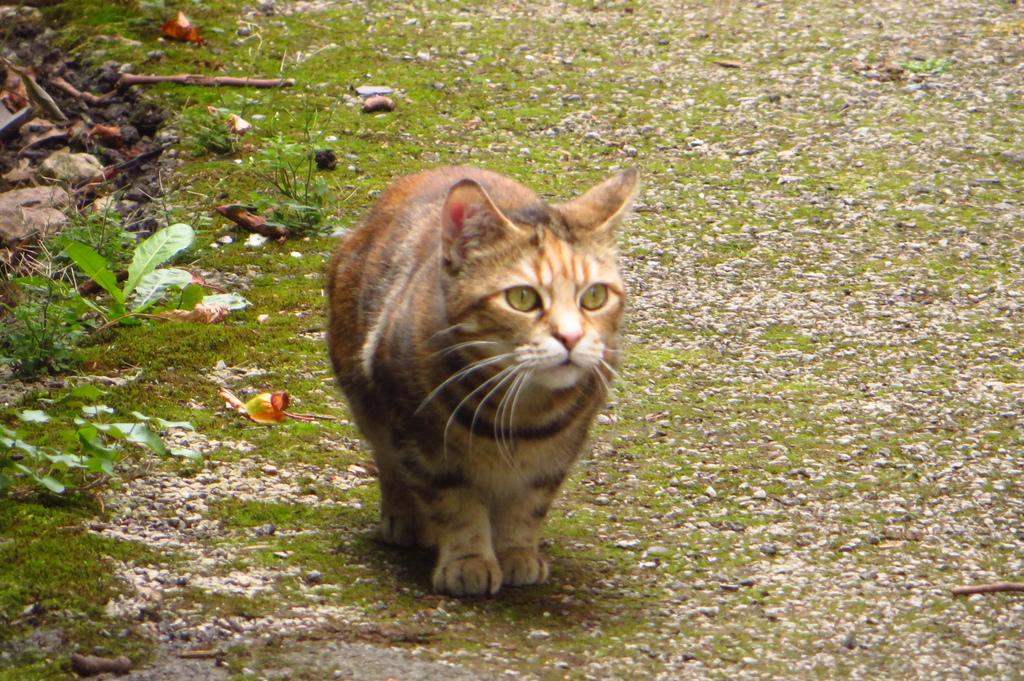What animal can be seen in the picture? There is a cat in the picture. What is the cat doing in the picture? The cat is walking on the grass. What can be found beside the cat in the picture? There are leaves and stones beside the cat. Can you describe the thickness of the fog in the image? There is no fog present in the image; it features a cat walking on the grass with leaves and stones beside it. 